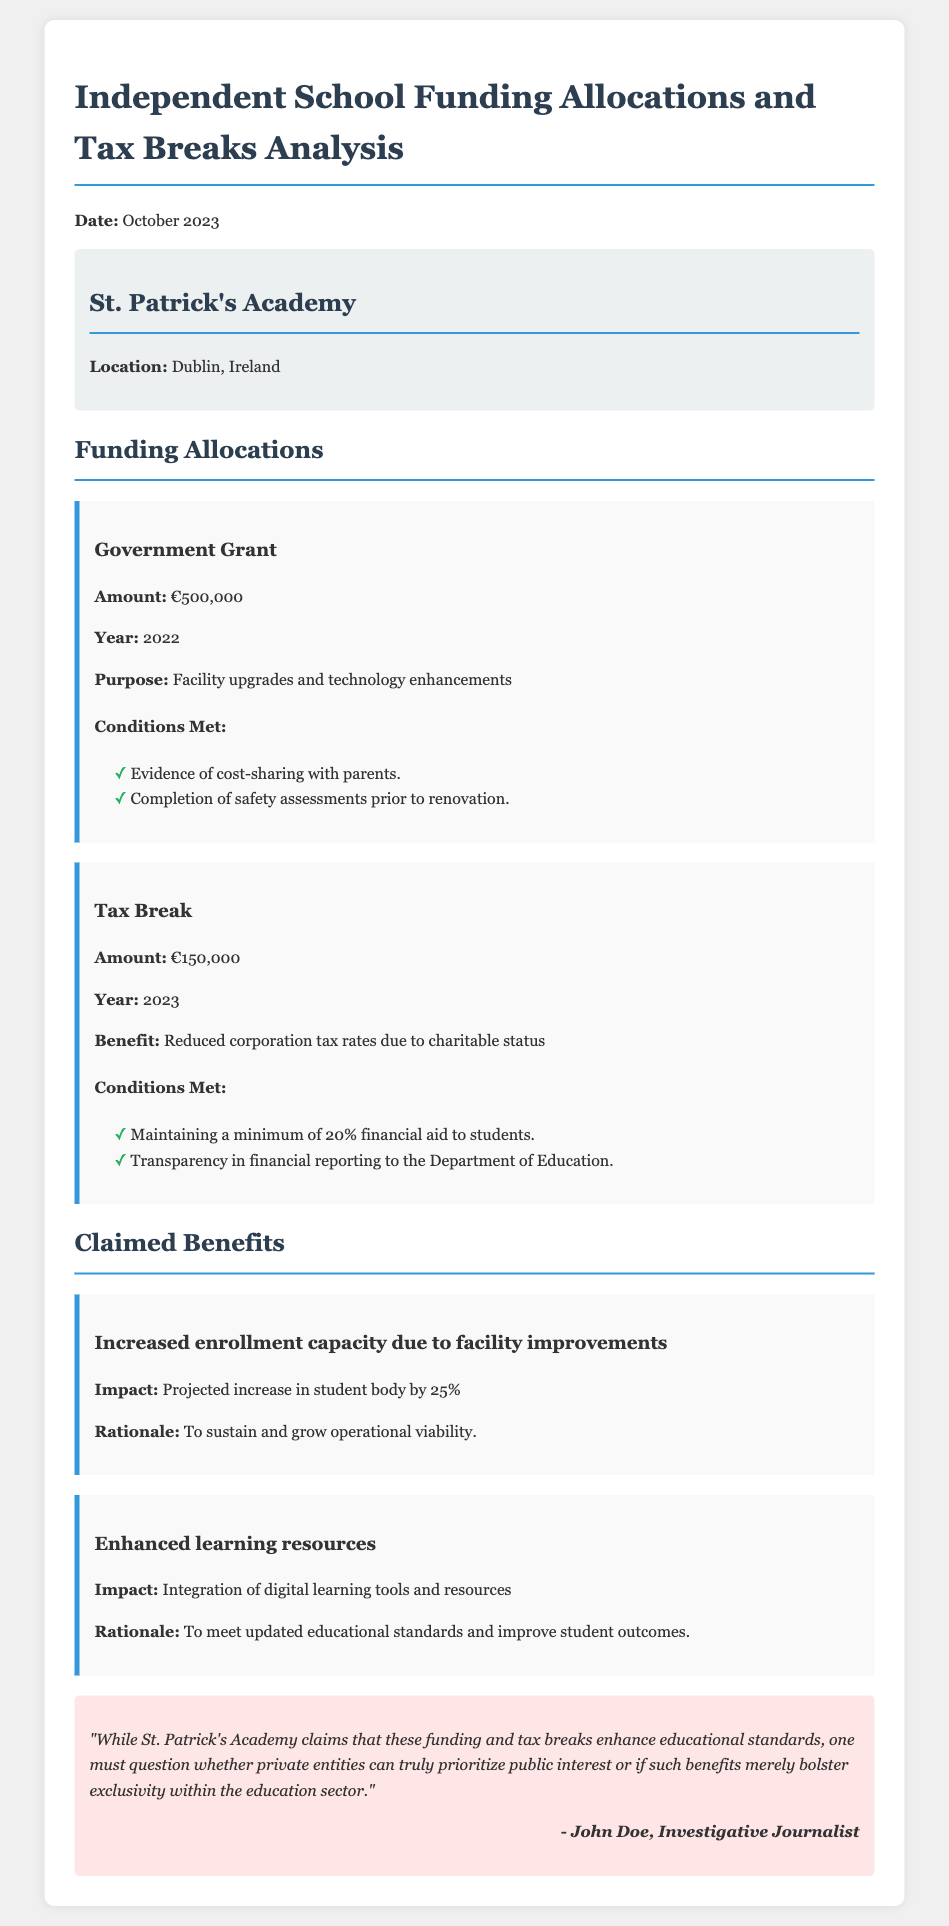What is the name of the independent school discussed? The document mentions "St. Patrick's Academy" as the independent school being analyzed.
Answer: St. Patrick's Academy What is the location of St. Patrick's Academy? The document specifies that St. Patrick's Academy is located in Dublin, Ireland.
Answer: Dublin, Ireland How much was the government grant allocated in 2022? The document states that the government grant amount for 2022 was €500,000.
Answer: €500,000 What percentage of financial aid must be maintained for the tax break? The document indicates that a minimum of 20% financial aid to students is required for the tax break conditions.
Answer: 20% What is the projected increase in student body due to facility improvements? According to the document, there is a projected increase in student body by 25% due to the facility improvements.
Answer: 25% What was the purpose of the €500,000 government grant? The document outlines that the purpose of the grant was for facility upgrades and technology enhancements at the school.
Answer: Facility upgrades and technology enhancements What is one claimed benefit of the funding? The document mentions "Increased enrollment capacity due to facility improvements" as one of the claimed benefits.
Answer: Increased enrollment capacity What skepticism is expressed in the document? The skepticism expressed questions whether private entities can prioritize public interest based on claims made by the school regarding funding benefits.
Answer: Prioritize public interest What year did the tax break of €150,000 arise? The document states that the tax break of €150,000 was for the year 2023.
Answer: 2023 